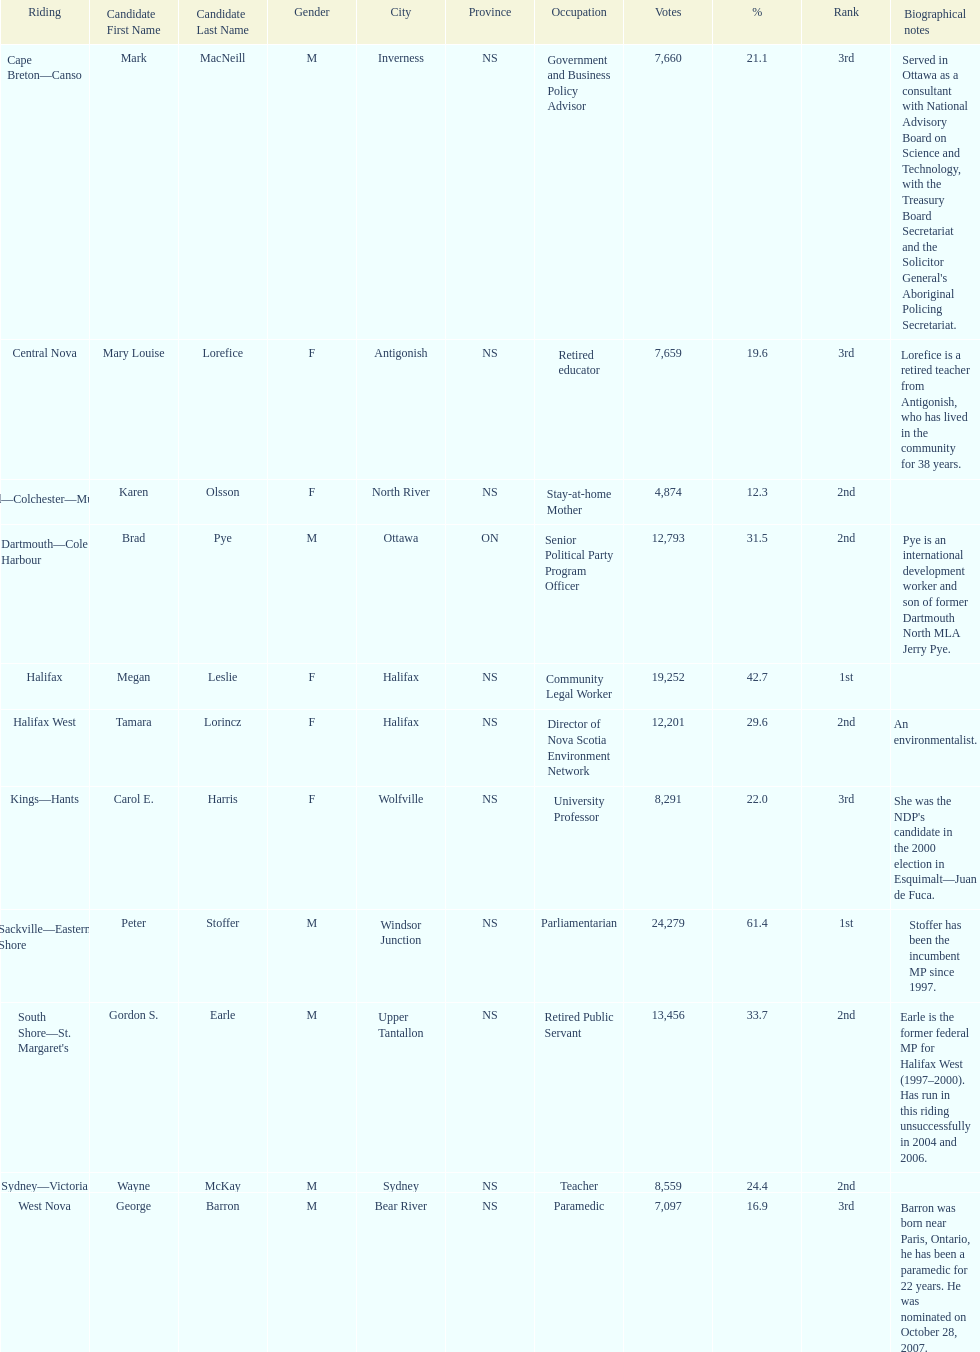Who has the most votes? Sackville-Eastern Shore. 